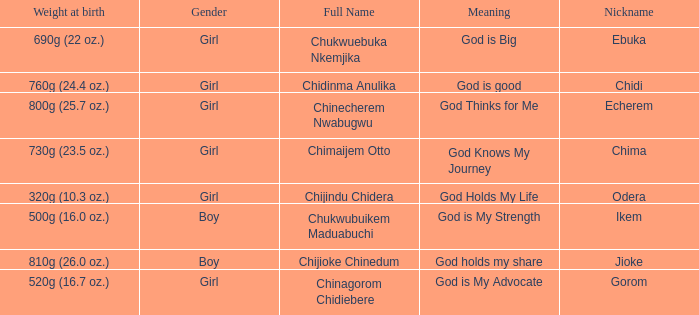How much did the baby who name means God knows my journey weigh at birth? 730g (23.5 oz.). 